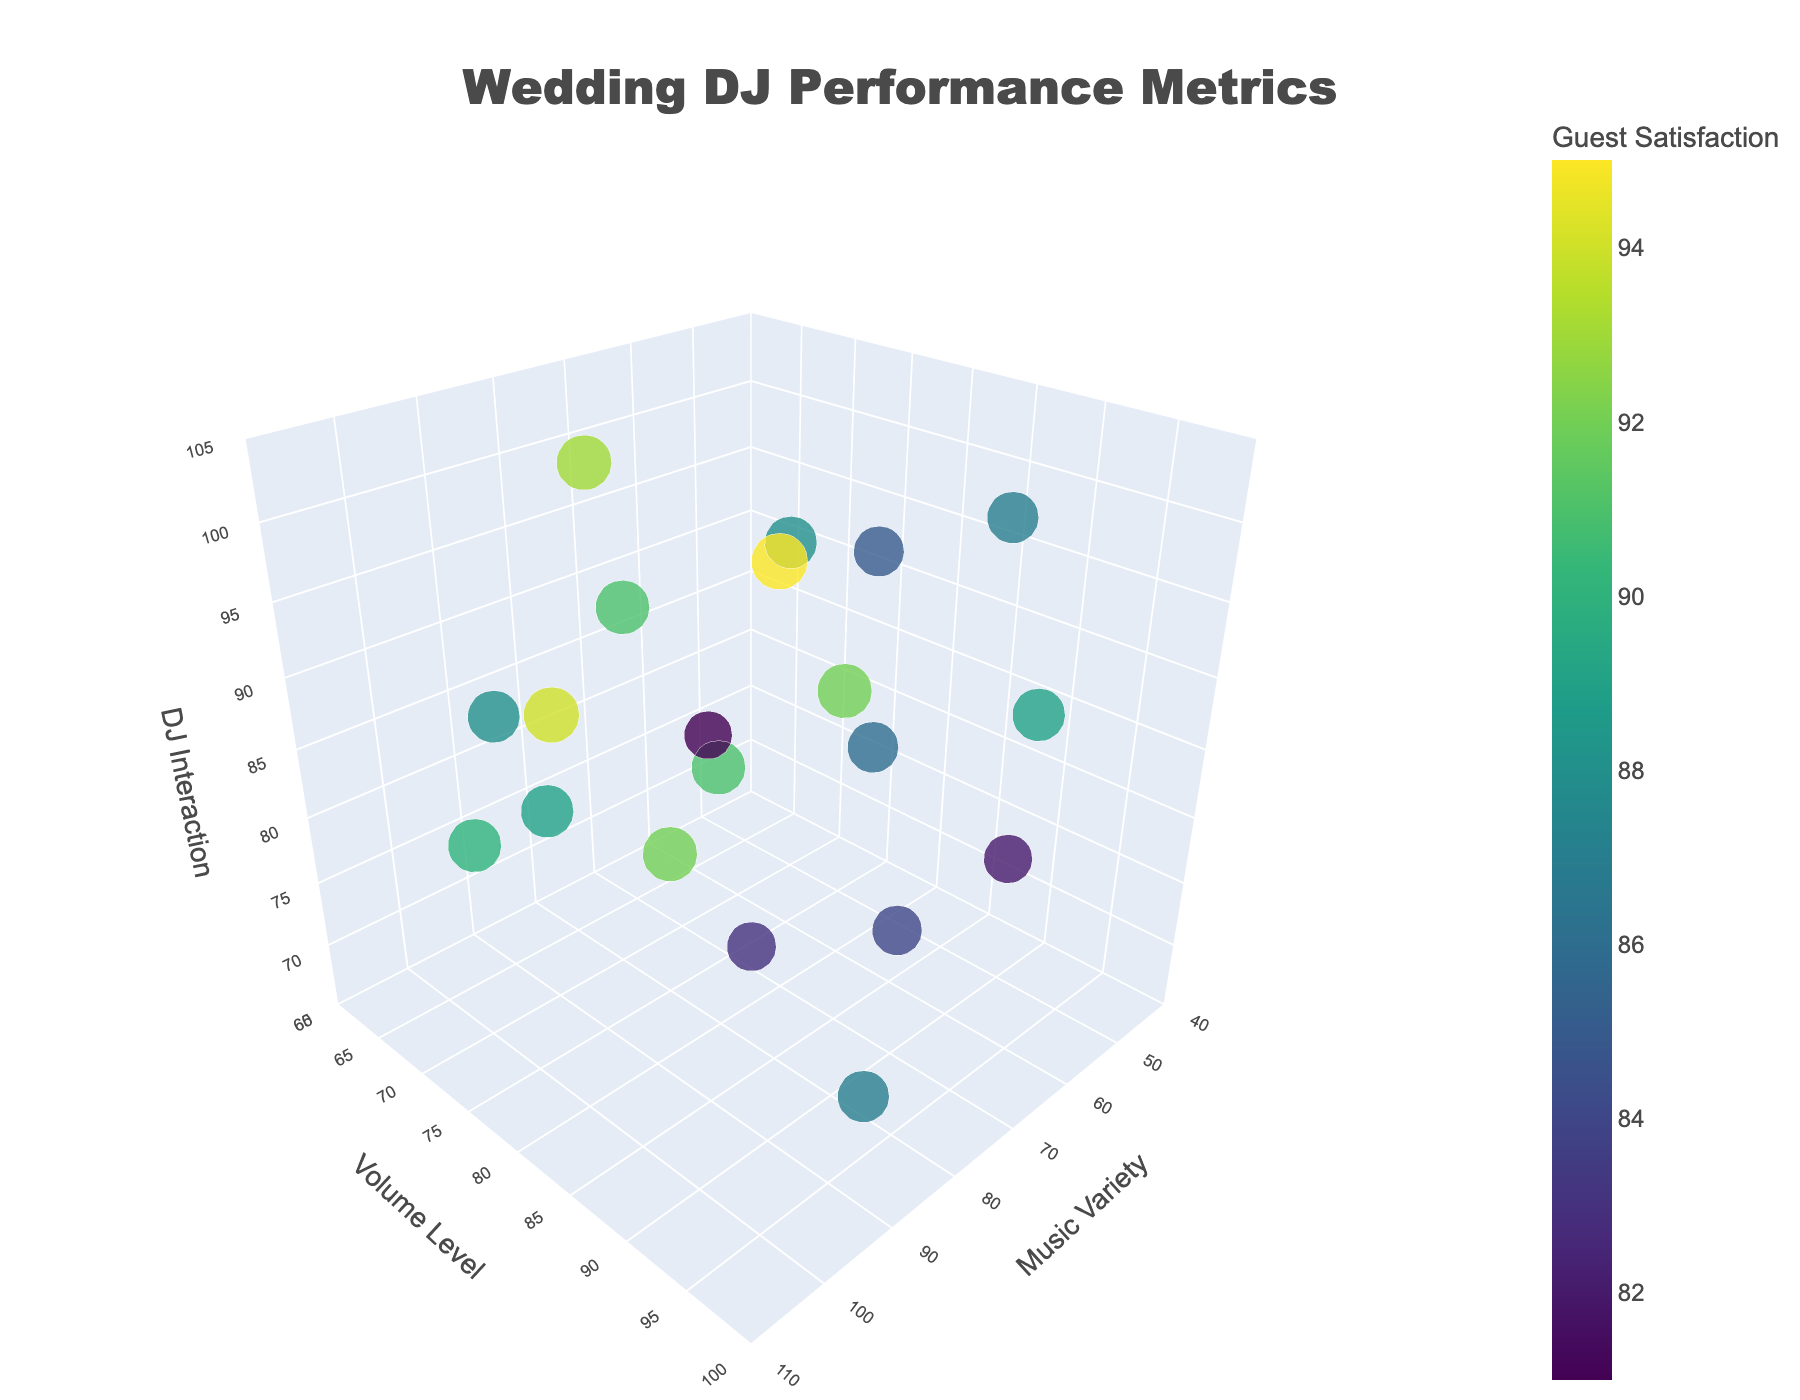How many data points are displayed in the plot? Count the number of individual markers (data points) displayed in the 3D plot. Each marker represents a pair of values inputting from music variety, volume level, and DJ interaction, resulting in a total number of points equivalent to the number of rows in the dataset.
Answer: 20 What is the title of the figure? The title is displayed prominently at the top center of the plot.
Answer: Wedding DJ Performance Metrics Which axis represents the music variety? Look at the labels of each axis to identify which one corresponds to music variety.
Answer: X-axis Which data point has the highest guest satisfaction? Hover over each data point to see the guest satisfaction score. The one with the highest score should be identified.
Answer: The data point with Music Variety 80, Volume Level 85, DJ Interaction 100 What is the range of the Volume Level axis? Examine the minimum and maximum values labeled on the Volume Level axis to determine its range.
Answer: 60-100 How does guest satisfaction change with variations in music variety and DJ interaction for Volume Level 90? Identify and compare the data points where Volume Level is 90 and observe the relationship between Music Variety, DJ Interaction, and Guest Satisfaction. For instance, a higher music variety and DJ interaction usually correlate with higher guest satisfaction.
Answer: Increases with higher values Which data point shows the lowest DJ interaction? Hover over the points to find the one with the lowest DJ Interaction value.
Answer: The data point with Music Variety 85, Volume Level 95, DJ Interaction 70 Are there more data points with DJ interaction above 90 or below 90? Count the number of data points with DJ interaction values above and below 90 to determine which group is larger.
Answer: Below 90 Is guest satisfaction always higher with high DJ interaction values? Compare guest satisfaction scores across different data points with high DJ interaction values. While generally higher, not always. Check for outliers where high DJ interaction doesn't lead to the highest guest satisfaction.
Answer: Generally yes, but not always Which combination of music variety and volume level results in the highest average guest satisfaction? Calculate the average guest satisfaction for each possible combination of Music Variety and Volume Level by averaging the Guest Satisfaction values of all points with the same music variety and volume level. Identify the highest mean.
Answer: Music Variety 80, Volume Level 85 